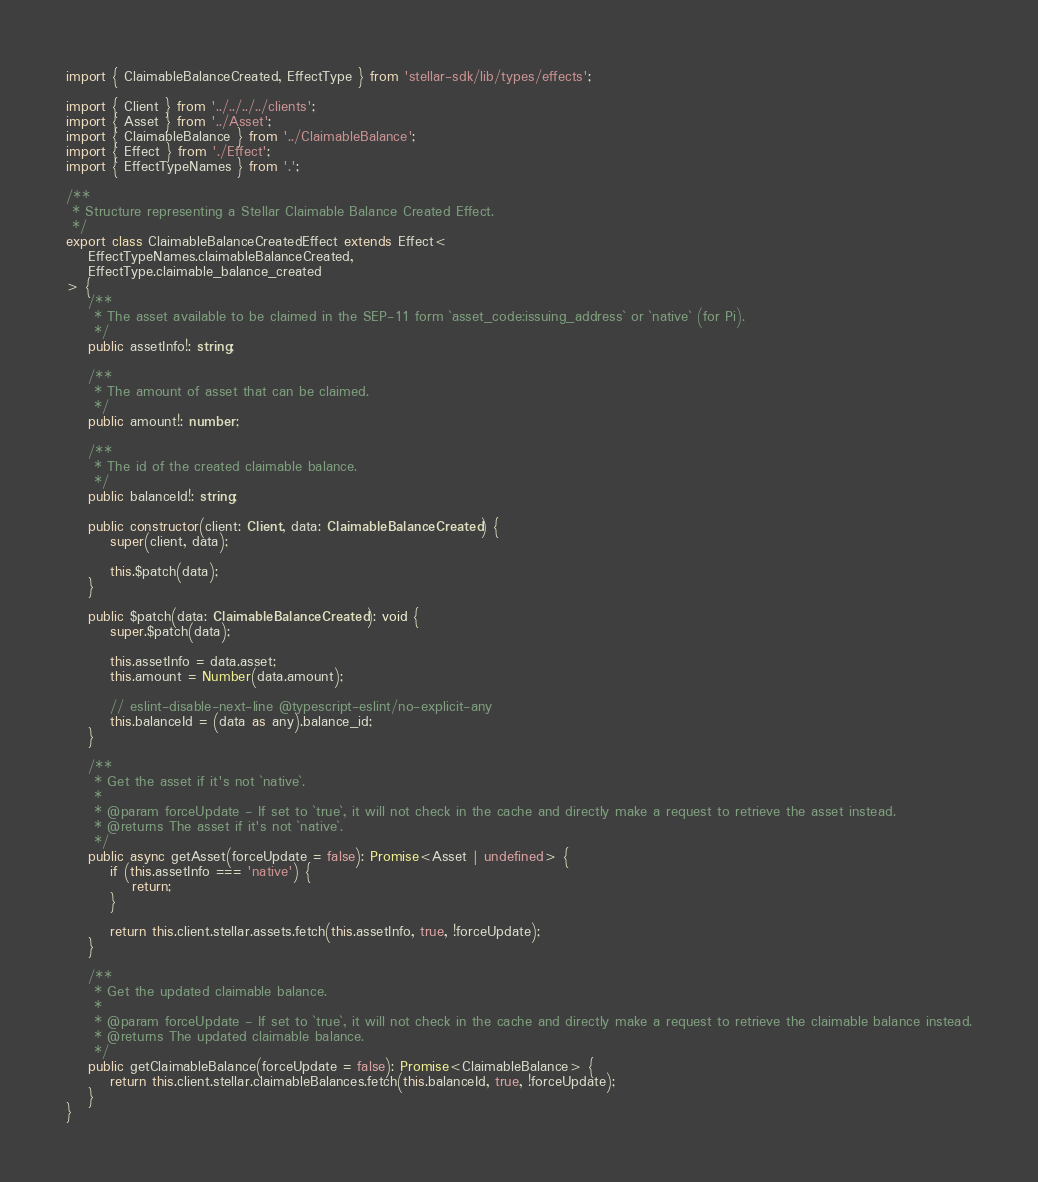Convert code to text. <code><loc_0><loc_0><loc_500><loc_500><_TypeScript_>import { ClaimableBalanceCreated, EffectType } from 'stellar-sdk/lib/types/effects';

import { Client } from '../../../../clients';
import { Asset } from '../Asset';
import { ClaimableBalance } from '../ClaimableBalance';
import { Effect } from './Effect';
import { EffectTypeNames } from '.';

/**
 * Structure representing a Stellar Claimable Balance Created Effect.
 */
export class ClaimableBalanceCreatedEffect extends Effect<
	EffectTypeNames.claimableBalanceCreated,
	EffectType.claimable_balance_created
> {
	/**
	 * The asset available to be claimed in the SEP-11 form `asset_code:issuing_address` or `native` (for Pi).
	 */
	public assetInfo!: string;

	/**
	 * The amount of asset that can be claimed.
	 */
	public amount!: number;

	/**
	 * The id of the created claimable balance.
	 */
	public balanceId!: string;

	public constructor(client: Client, data: ClaimableBalanceCreated) {
		super(client, data);

		this.$patch(data);
	}

	public $patch(data: ClaimableBalanceCreated): void {
		super.$patch(data);

		this.assetInfo = data.asset;
		this.amount = Number(data.amount);

		// eslint-disable-next-line @typescript-eslint/no-explicit-any
		this.balanceId = (data as any).balance_id;
	}

	/**
	 * Get the asset if it's not `native`.
	 *
	 * @param forceUpdate - If set to `true`, it will not check in the cache and directly make a request to retrieve the asset instead.
	 * @returns The asset if it's not `native`.
	 */
	public async getAsset(forceUpdate = false): Promise<Asset | undefined> {
		if (this.assetInfo === 'native') {
			return;
		}

		return this.client.stellar.assets.fetch(this.assetInfo, true, !forceUpdate);
	}

	/**
	 * Get the updated claimable balance.
	 *
	 * @param forceUpdate - If set to `true`, it will not check in the cache and directly make a request to retrieve the claimable balance instead.
	 * @returns The updated claimable balance.
	 */
	public getClaimableBalance(forceUpdate = false): Promise<ClaimableBalance> {
		return this.client.stellar.claimableBalances.fetch(this.balanceId, true, !forceUpdate);
	}
}
</code> 